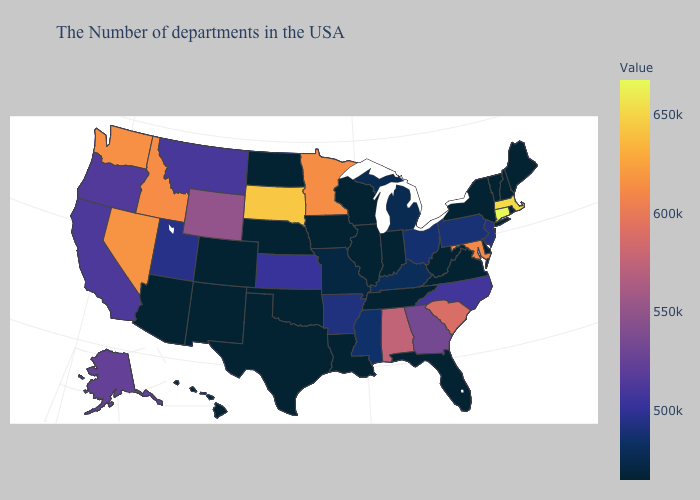Which states have the highest value in the USA?
Quick response, please. Connecticut. Among the states that border Mississippi , does Arkansas have the highest value?
Short answer required. No. Which states have the lowest value in the MidWest?
Answer briefly. Indiana, Wisconsin, Illinois, Iowa, Nebraska, North Dakota. Among the states that border Montana , which have the highest value?
Quick response, please. South Dakota. Does Nevada have the highest value in the West?
Concise answer only. Yes. Among the states that border North Dakota , does South Dakota have the highest value?
Keep it brief. Yes. 